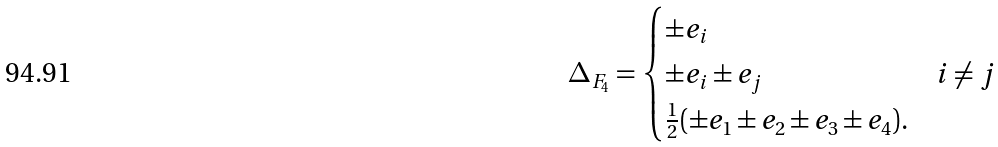<formula> <loc_0><loc_0><loc_500><loc_500>\Delta _ { F _ { 4 } } = \begin{cases} \pm e _ { i } \\ \pm e _ { i } \pm e _ { j } & i \neq j \\ \frac { 1 } { 2 } ( \pm e _ { 1 } \pm e _ { 2 } \pm e _ { 3 } \pm e _ { 4 } ) . \end{cases}</formula> 